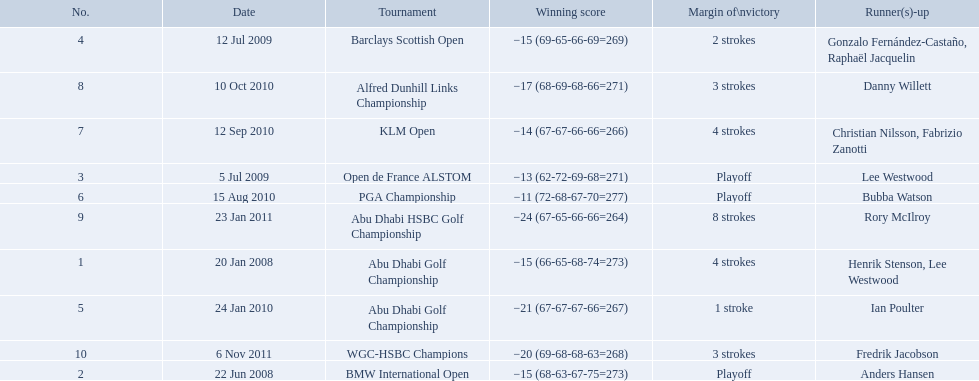What were all the different tournaments played by martin kaymer Abu Dhabi Golf Championship, BMW International Open, Open de France ALSTOM, Barclays Scottish Open, Abu Dhabi Golf Championship, PGA Championship, KLM Open, Alfred Dunhill Links Championship, Abu Dhabi HSBC Golf Championship, WGC-HSBC Champions. Who was the runner-up for the pga championship? Bubba Watson. What were the margins of victories of the tournaments? 4 strokes, Playoff, Playoff, 2 strokes, 1 stroke, Playoff, 4 strokes, 3 strokes, 8 strokes, 3 strokes. Of these, what was the margin of victory of the klm and the barklay 2 strokes, 4 strokes. What were the difference between these? 2 strokes. 